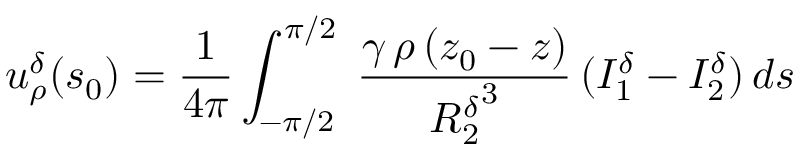Convert formula to latex. <formula><loc_0><loc_0><loc_500><loc_500>u _ { \rho } ^ { \delta } ( s _ { 0 } ) = \frac { 1 } { 4 \pi } \int _ { - \pi / 2 } ^ { \pi / 2 } \, \frac { \gamma \, \rho \, ( z _ { 0 } - z ) } { { R _ { 2 } ^ { \delta } } ^ { 3 } } \, ( I _ { 1 } ^ { \delta } - I _ { 2 } ^ { \delta } ) \, d s</formula> 